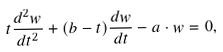<formula> <loc_0><loc_0><loc_500><loc_500>t \frac { d ^ { 2 } w } { d t ^ { 2 } } + ( b - t ) \frac { d w } { d t } - a \cdot w = 0 ,</formula> 